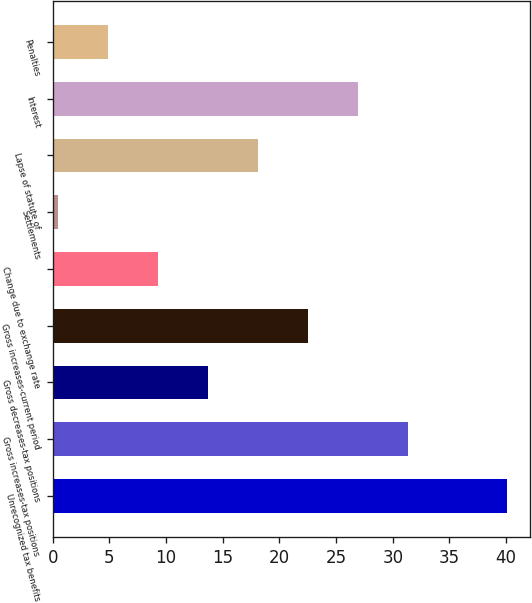Convert chart. <chart><loc_0><loc_0><loc_500><loc_500><bar_chart><fcel>Unrecognized tax benefits<fcel>Gross increases-tax positions<fcel>Gross decreases-tax positions<fcel>Gross increases-current period<fcel>Change due to exchange rate<fcel>Settlements<fcel>Lapse of statute of<fcel>Interest<fcel>Penalties<nl><fcel>40.1<fcel>31.3<fcel>13.7<fcel>22.5<fcel>9.3<fcel>0.5<fcel>18.1<fcel>26.9<fcel>4.9<nl></chart> 